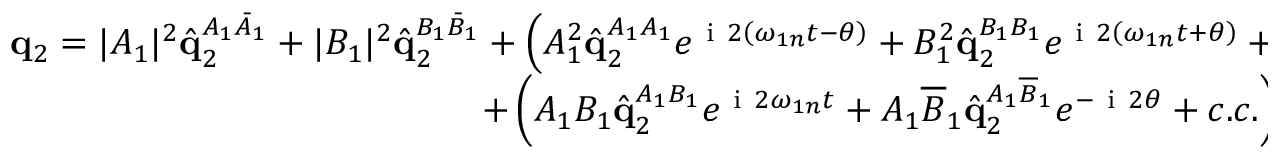Convert formula to latex. <formula><loc_0><loc_0><loc_500><loc_500>\begin{array} { r } { q _ { 2 } = | A _ { 1 } | ^ { 2 } \hat { q } _ { 2 } ^ { A _ { 1 } \bar { A } _ { 1 } } + | B _ { 1 } | ^ { 2 } \hat { q } _ { 2 } ^ { B _ { 1 } \bar { B } _ { 1 } } + \left ( A _ { 1 } ^ { 2 } \hat { q } _ { 2 } ^ { A _ { 1 } A _ { 1 } } e ^ { i 2 \left ( \omega _ { 1 n } t - \theta \right ) } + B _ { 1 } ^ { 2 } \hat { q } _ { 2 } ^ { B _ { 1 } B _ { 1 } } e ^ { i 2 \left ( \omega _ { 1 n } t + \theta \right ) } + c . c . \right ) } \\ { + \left ( A _ { 1 } B _ { 1 } \hat { q } _ { 2 } ^ { A _ { 1 } B _ { 1 } } e ^ { i 2 \omega _ { 1 n } t } + A _ { 1 } \overline { B } _ { 1 } \hat { q } _ { 2 } ^ { A _ { 1 } \overline { B } _ { 1 } } e ^ { - i 2 \theta } + c . c . \right ) . \quad \ } \end{array}</formula> 